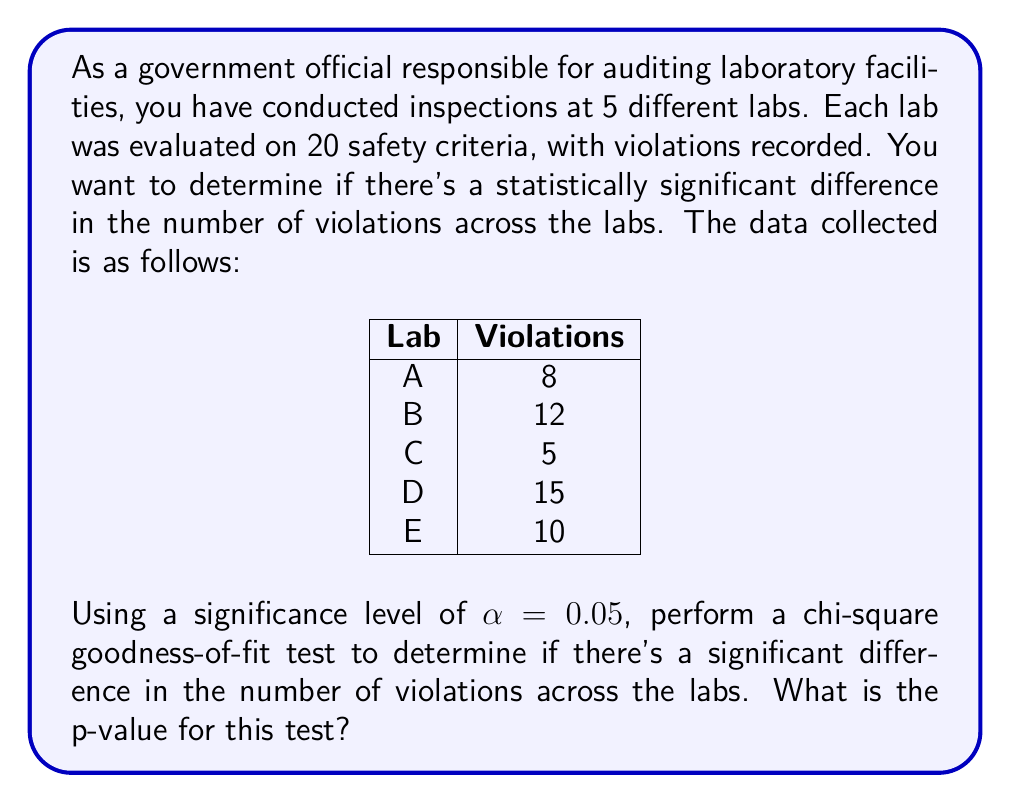Could you help me with this problem? To solve this problem, we'll use the chi-square goodness-of-fit test. This test is appropriate when we want to compare observed frequencies to expected frequencies across multiple categories.

Step 1: State the null and alternative hypotheses.
$H_0$: The number of violations is evenly distributed across all labs.
$H_a$: The number of violations is not evenly distributed across all labs.

Step 2: Calculate the expected frequency for each lab.
Total violations = 8 + 12 + 5 + 15 + 10 = 50
Number of labs = 5
Expected frequency for each lab = 50 / 5 = 10

Step 3: Calculate the chi-square statistic.
$$\chi^2 = \sum\frac{(O_i - E_i)^2}{E_i}$$

Where $O_i$ is the observed frequency and $E_i$ is the expected frequency.

$$\chi^2 = \frac{(8-10)^2}{10} + \frac{(12-10)^2}{10} + \frac{(5-10)^2}{10} + \frac{(15-10)^2}{10} + \frac{(10-10)^2}{10}$$
$$\chi^2 = 0.4 + 0.4 + 2.5 + 2.5 + 0 = 5.8$$

Step 4: Determine the degrees of freedom (df).
df = number of categories - 1 = 5 - 1 = 4

Step 5: Find the p-value.
Using a chi-square distribution table or calculator with df = 4 and $\chi^2 = 5.8$, we find the p-value.

p-value ≈ 0.2148

Step 6: Compare the p-value to the significance level.
Since 0.2148 > 0.05, we fail to reject the null hypothesis.
Answer: The p-value for the chi-square goodness-of-fit test is approximately 0.2148. 